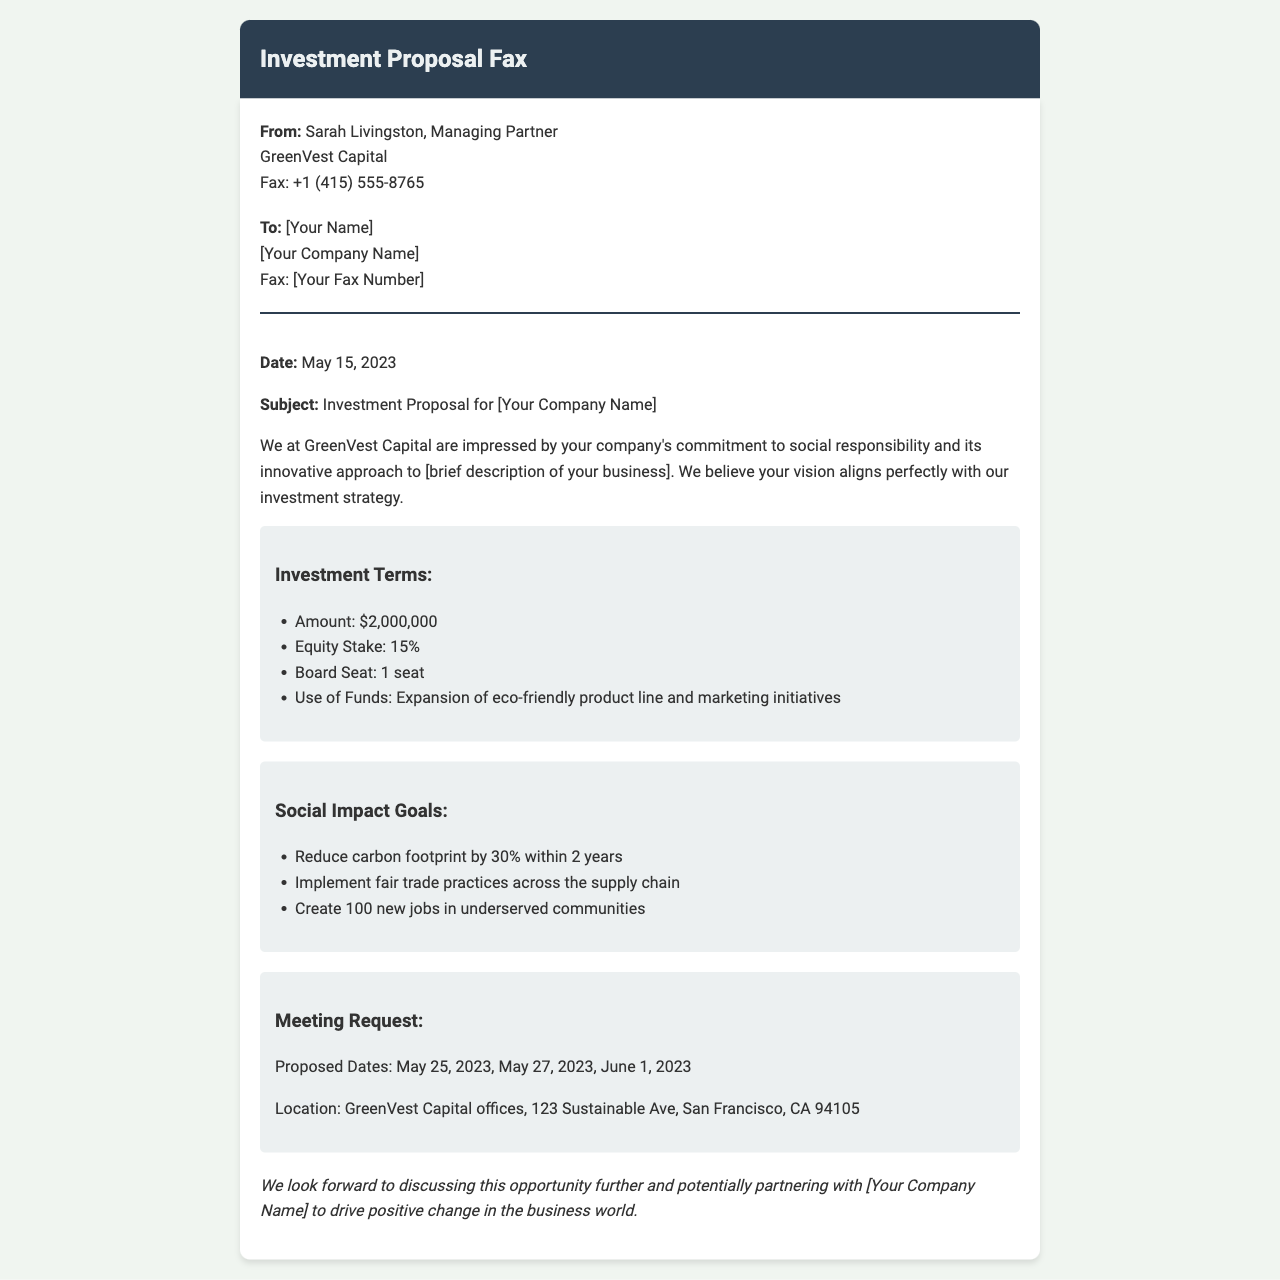what is the investment amount proposed? The investment amount proposed is stated clearly in the document.
Answer: $2,000,000 who is the sender of the fax? The sender's name and company are mentioned at the top of the document.
Answer: Sarah Livingston, Managing Partner, GreenVest Capital what is the proposed equity stake? The equity stake is listed under the investment terms section.
Answer: 15% what are the proposed meeting dates? The proposed meeting dates are explicitly specified in the meeting request section.
Answer: May 25, 2023, May 27, 2023, June 1, 2023 what is one of the social impact goals mentioned? The social impact goals are detailed in a list, indicating specific aims for the investment.
Answer: Reduce carbon footprint by 30% within 2 years who is the recipient of the fax? The recipient's name and company are referenced in the document, though placeholders may be used.
Answer: [Your Name], [Your Company Name] what is the location of the proposed meeting? The location for the proposed meeting is indicated within the document.
Answer: GreenVest Capital offices, 123 Sustainable Ave, San Francisco, CA 94105 